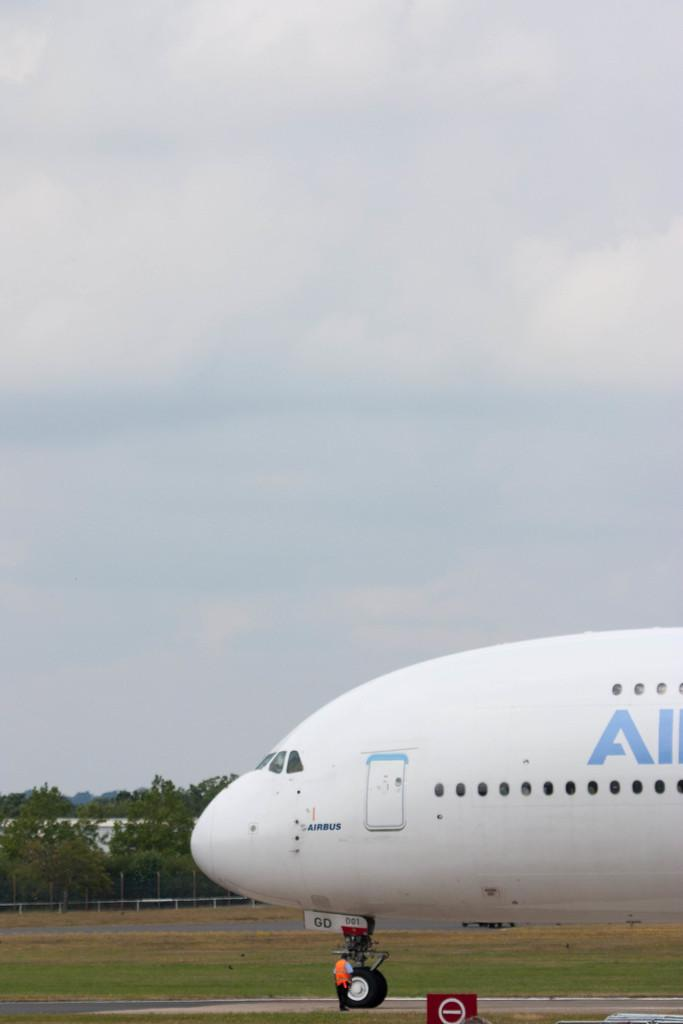What is the main subject of the picture? The main subject of the picture is an airplane. Can you describe the person in the picture? There is a person standing in the picture. What is the fence used for in the picture? The fence is in the picture, but its purpose is not specified. What type of vegetation is in the picture? There are trees in the picture. What is visible at the top of the picture? The sky is visible at the top of the picture. What type of example does the person in the picture provide about pollution? There is no indication in the image that the person is providing an example about pollution. 